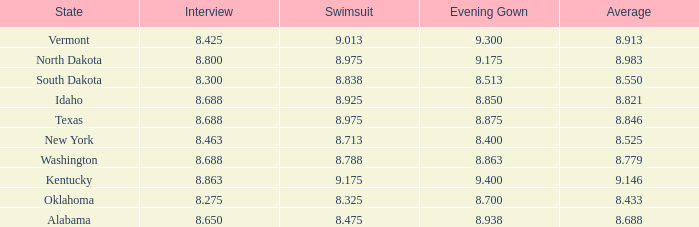What is the highest swimsuit score of the contestant with an evening gown larger than 9.175 and an interview score less than 8.425? None. 